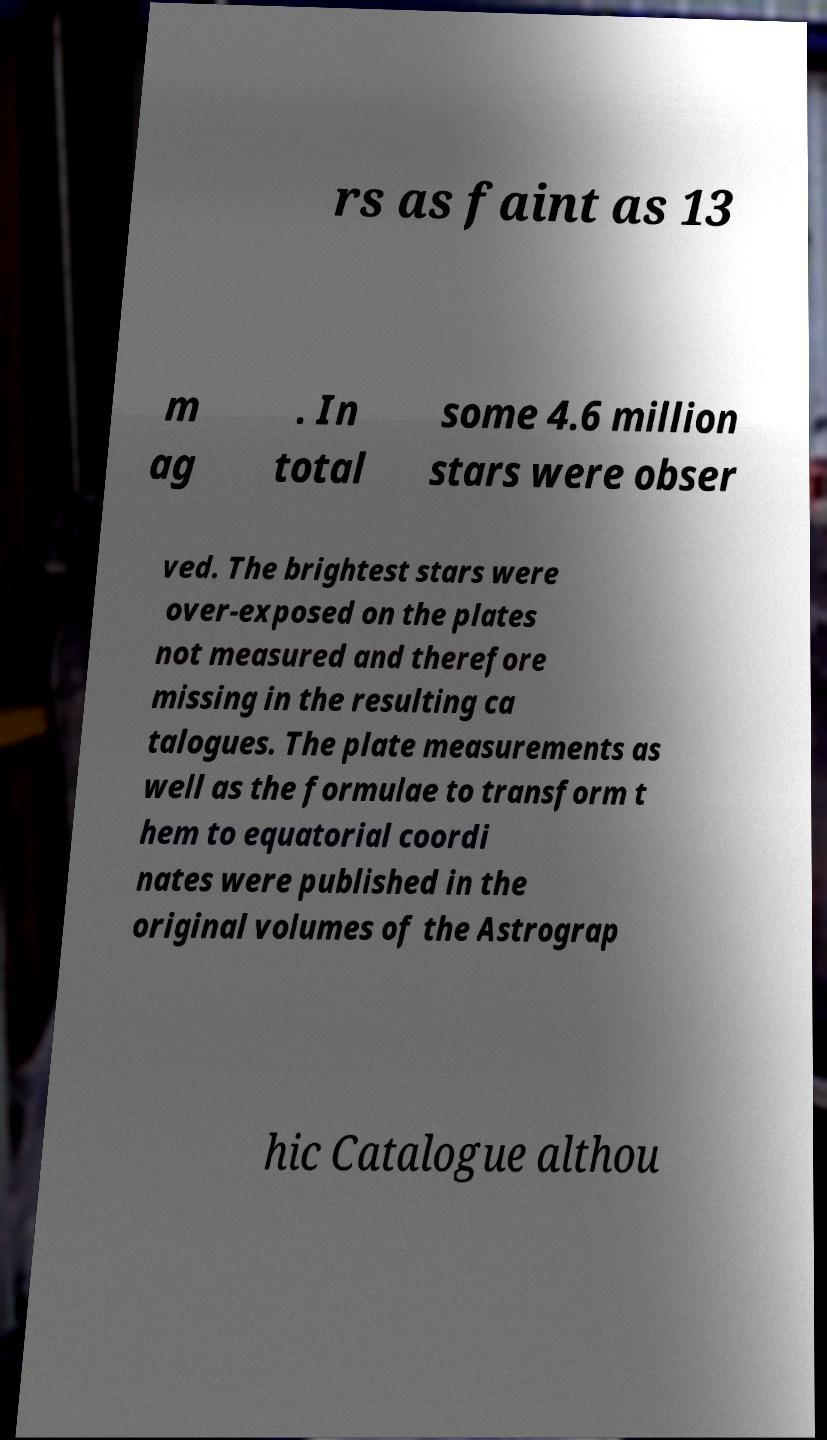Could you extract and type out the text from this image? rs as faint as 13 m ag . In total some 4.6 million stars were obser ved. The brightest stars were over-exposed on the plates not measured and therefore missing in the resulting ca talogues. The plate measurements as well as the formulae to transform t hem to equatorial coordi nates were published in the original volumes of the Astrograp hic Catalogue althou 